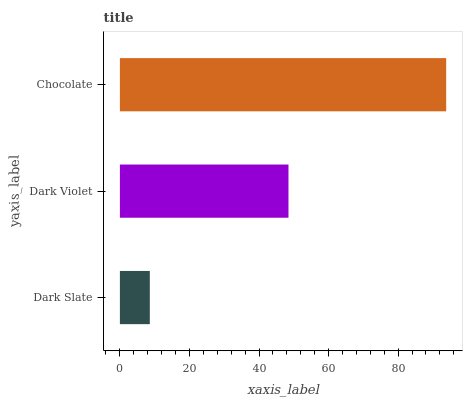Is Dark Slate the minimum?
Answer yes or no. Yes. Is Chocolate the maximum?
Answer yes or no. Yes. Is Dark Violet the minimum?
Answer yes or no. No. Is Dark Violet the maximum?
Answer yes or no. No. Is Dark Violet greater than Dark Slate?
Answer yes or no. Yes. Is Dark Slate less than Dark Violet?
Answer yes or no. Yes. Is Dark Slate greater than Dark Violet?
Answer yes or no. No. Is Dark Violet less than Dark Slate?
Answer yes or no. No. Is Dark Violet the high median?
Answer yes or no. Yes. Is Dark Violet the low median?
Answer yes or no. Yes. Is Chocolate the high median?
Answer yes or no. No. Is Dark Slate the low median?
Answer yes or no. No. 